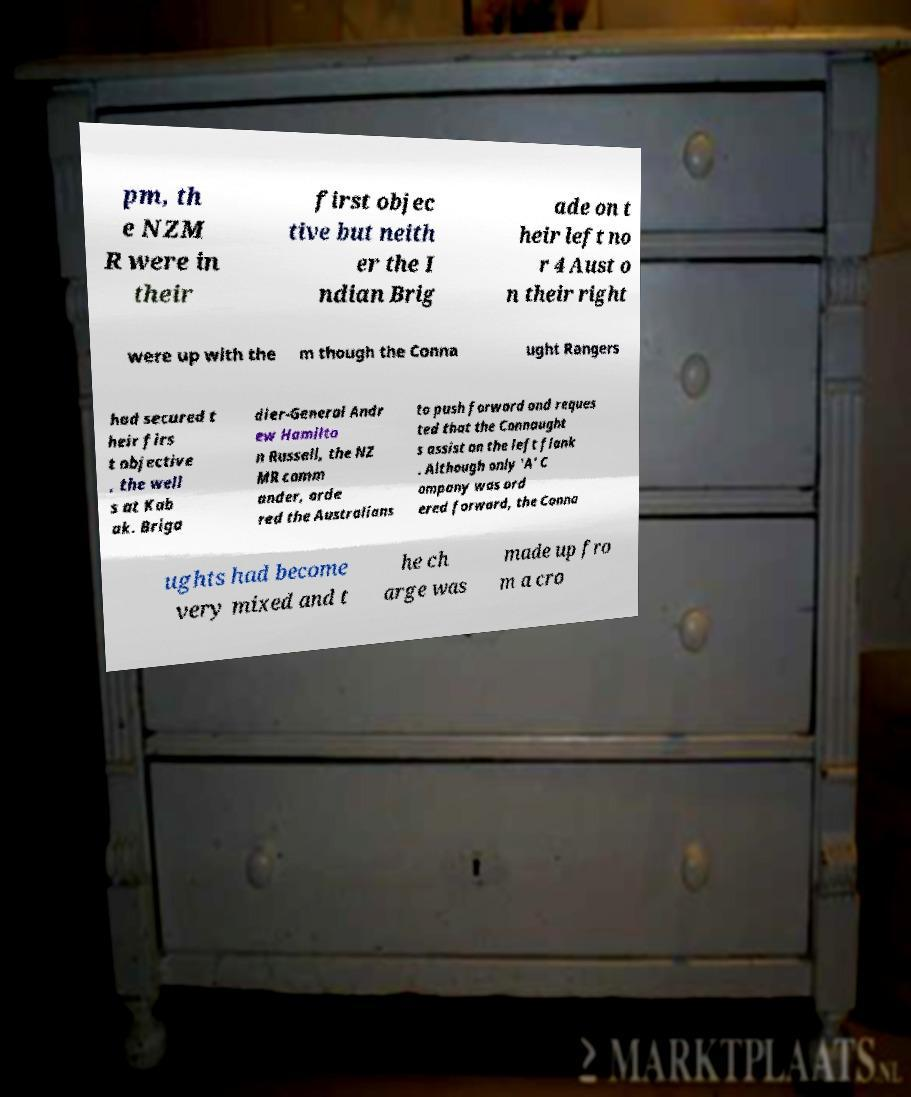There's text embedded in this image that I need extracted. Can you transcribe it verbatim? pm, th e NZM R were in their first objec tive but neith er the I ndian Brig ade on t heir left no r 4 Aust o n their right were up with the m though the Conna ught Rangers had secured t heir firs t objective , the well s at Kab ak. Briga dier-General Andr ew Hamilto n Russell, the NZ MR comm ander, orde red the Australians to push forward and reques ted that the Connaught s assist on the left flank . Although only 'A' C ompany was ord ered forward, the Conna ughts had become very mixed and t he ch arge was made up fro m a cro 